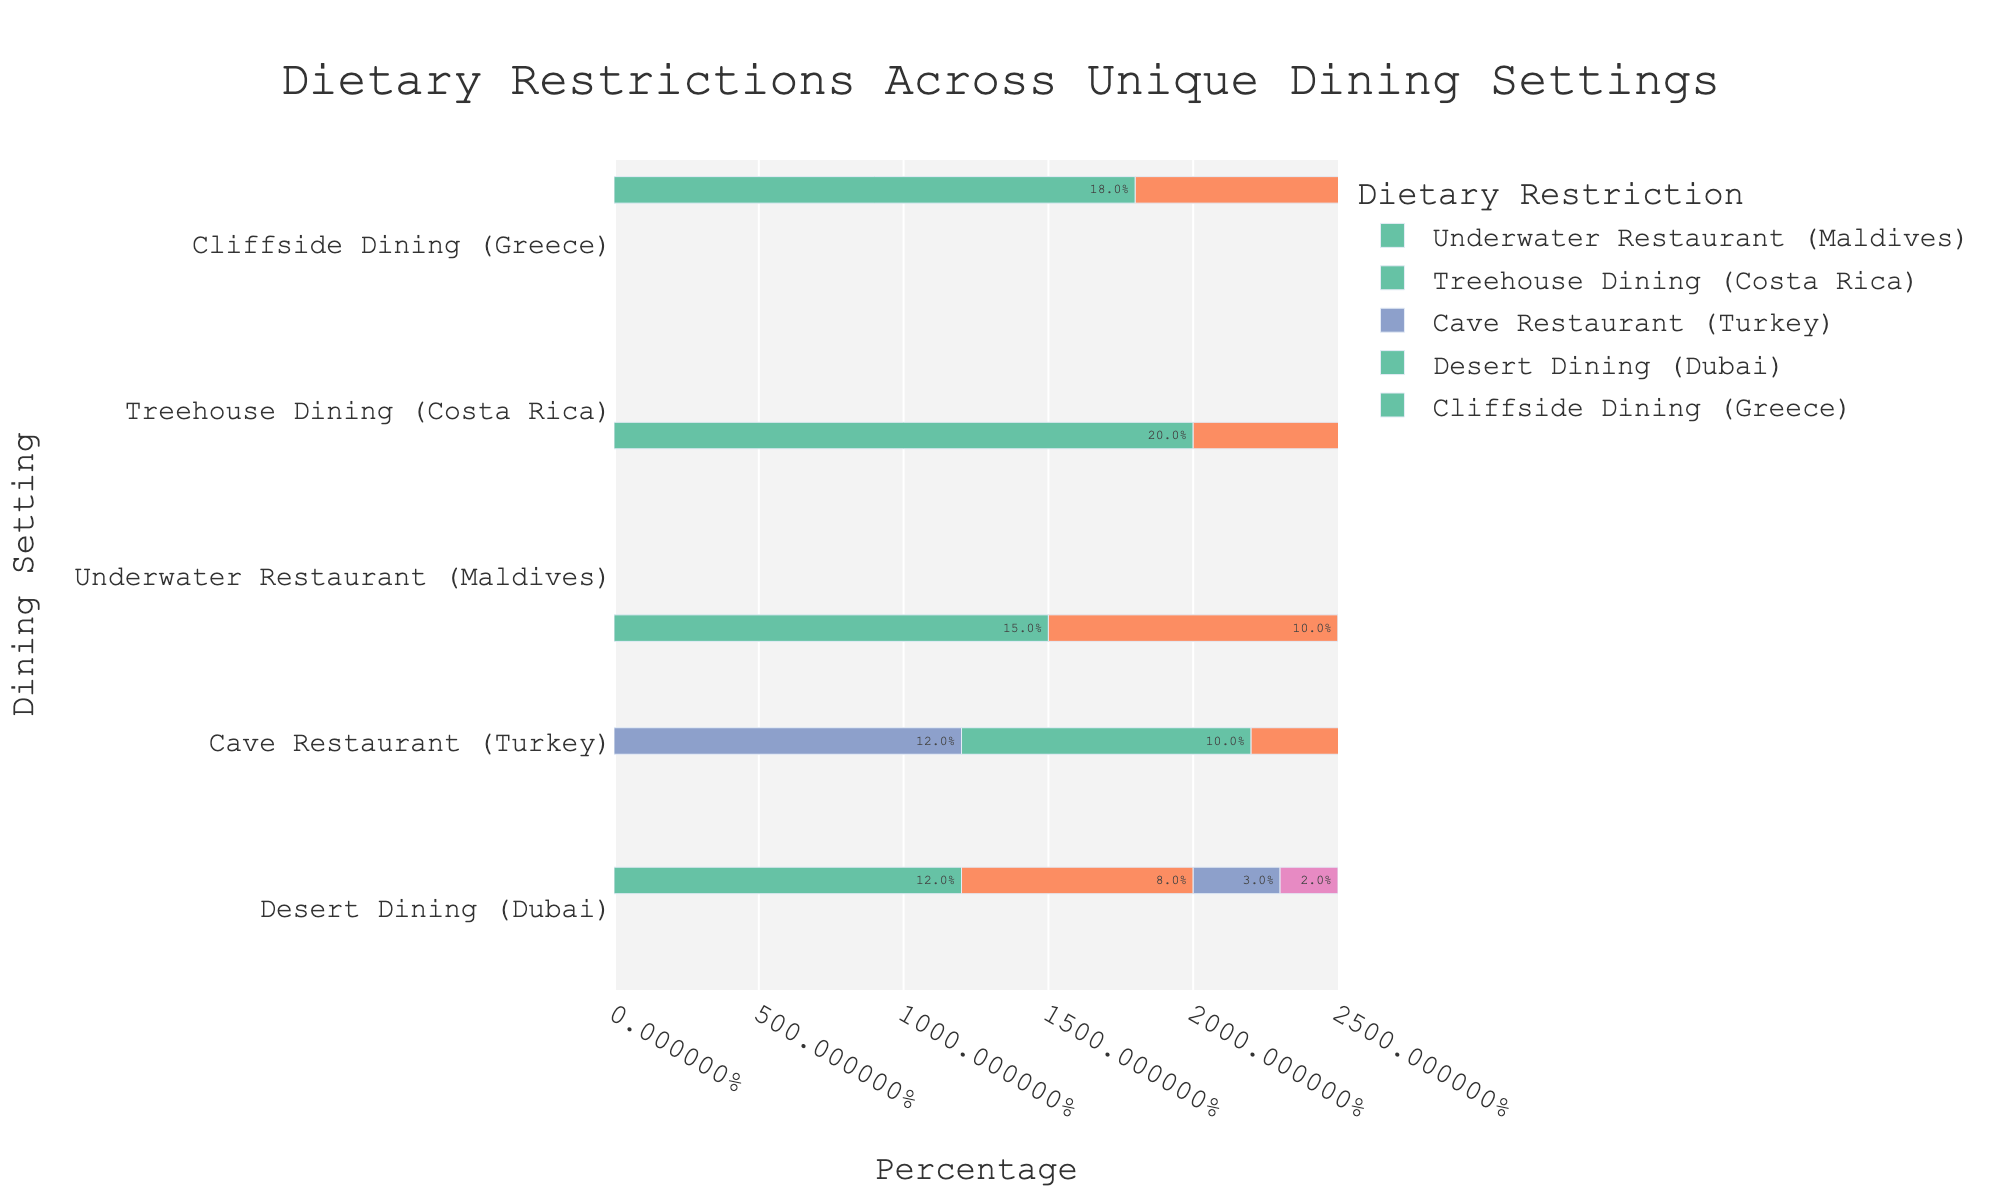Which dining setting has the highest percentage of vegetarian guests? By looking at the bars representing vegetarian dietary restriction, we can see that Treehouse Dining (Costa Rica) has the highest value at 20%.
Answer: Treehouse Dining (Costa Rica) Which dietary restriction is the most common in Cliffside Dining (Greece)? Observing the bars for Cliffside Dining (Greece), we can see that the vegetarian restriction has the highest percentage at 18%, followed closely by vegan at 15%.
Answer: Vegetarian What is the total percentage of guests with dietary restrictions at the Cave Restaurant (Turkey)? Summing up the percentages of all dietary restrictions for Cave Restaurant (Turkey): 10% (Vegetarian) + 5% (Vegan) + 12% (Gluten-Free) + 5% (Other) = 32%.
Answer: 32% How does the percentage of gluten-free guests in Desert Dining (Dubai) compare to Underwater Restaurant (Maldives)? Comparing the two settings, Desert Dining (Dubai) has 3% gluten-free guests while Underwater Restaurant (Maldives) has 5%. So, Underwater Restaurant (Maldives) has a higher percentage of gluten-free guests.
Answer: Underwater Restaurant (Maldives) Which dietary restriction has the lowest percentage in Treehouse Dining (Costa Rica)? Looking at the bars for Treehouse Dining (Costa Rica), the 'Other' dietary restriction has the lowest percentage at 5%.
Answer: Other What is the difference in the percentage of vegan guests between Treehouse Dining (Costa Rica) and Cliffside Dining (Greece)? Subtracting the percentage of vegan guests in Treehouse Dining (Costa Rica), which is 10%, from that in Cliffside Dining (Greece), which is 15%: 15% - 10% = 5%.
Answer: 5% Which dining setting has the most balanced distribution of dietary restrictions? The Cave Restaurant (Turkey) appears to have a balanced distribution given the relatively similar percentages: 10% Vegetarian, 5% Vegan, 12% Gluten-Free, and 5% Other.
Answer: Cave Restaurant (Turkey) How many dining settings have a higher percentage of vegan guests than gluten-free guests? Reviewing each setting: Underwater Restaurant (Maldives) has 10% vegan and 5% gluten-free; Treehouse Dining (Costa Rica) has 10% vegan and 7% gluten-free; Cave Restaurant (Turkey) has 5% vegan and 12% gluten-free; Desert Dining (Dubai) has 8% vegan and 3% gluten-free; Cliffside Dining (Greece) has 15% vegan and 5% gluten-free. Therefore, three settings (Underwater Restaurant, Treehouse Dining, and Cliffside Dining) have a higher percentage of vegan guests than gluten-free guests.
Answer: 3 settings 